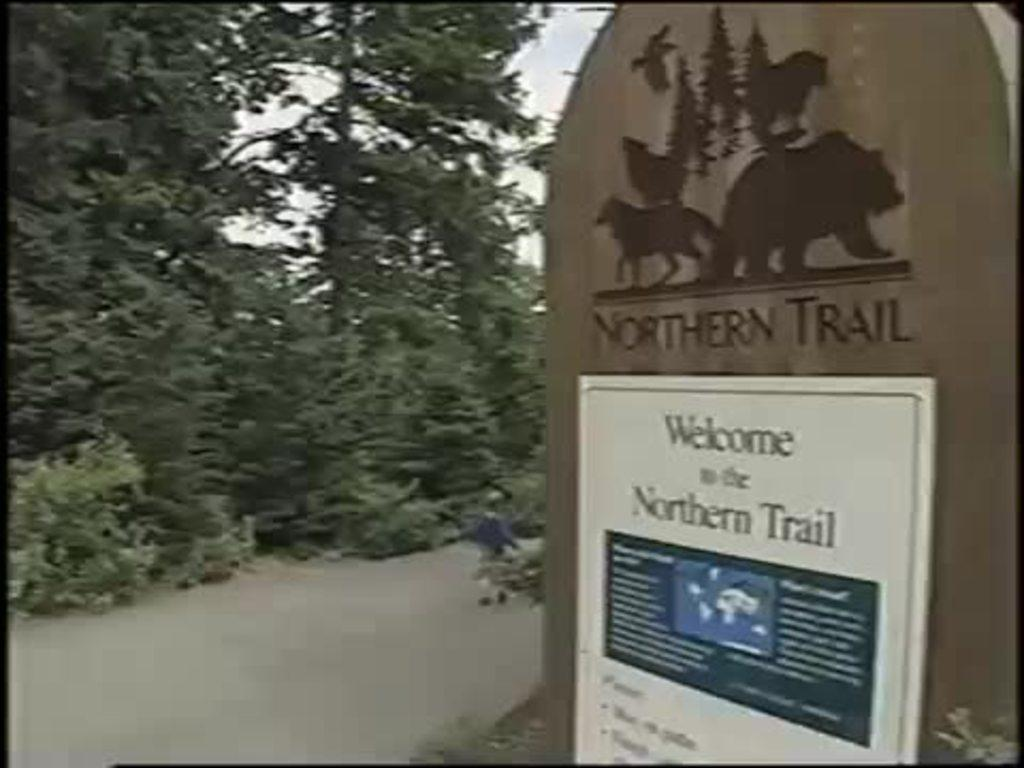Provide a one-sentence caption for the provided image. A sign indicates the entrance of the Northern Trail and states the rules. 